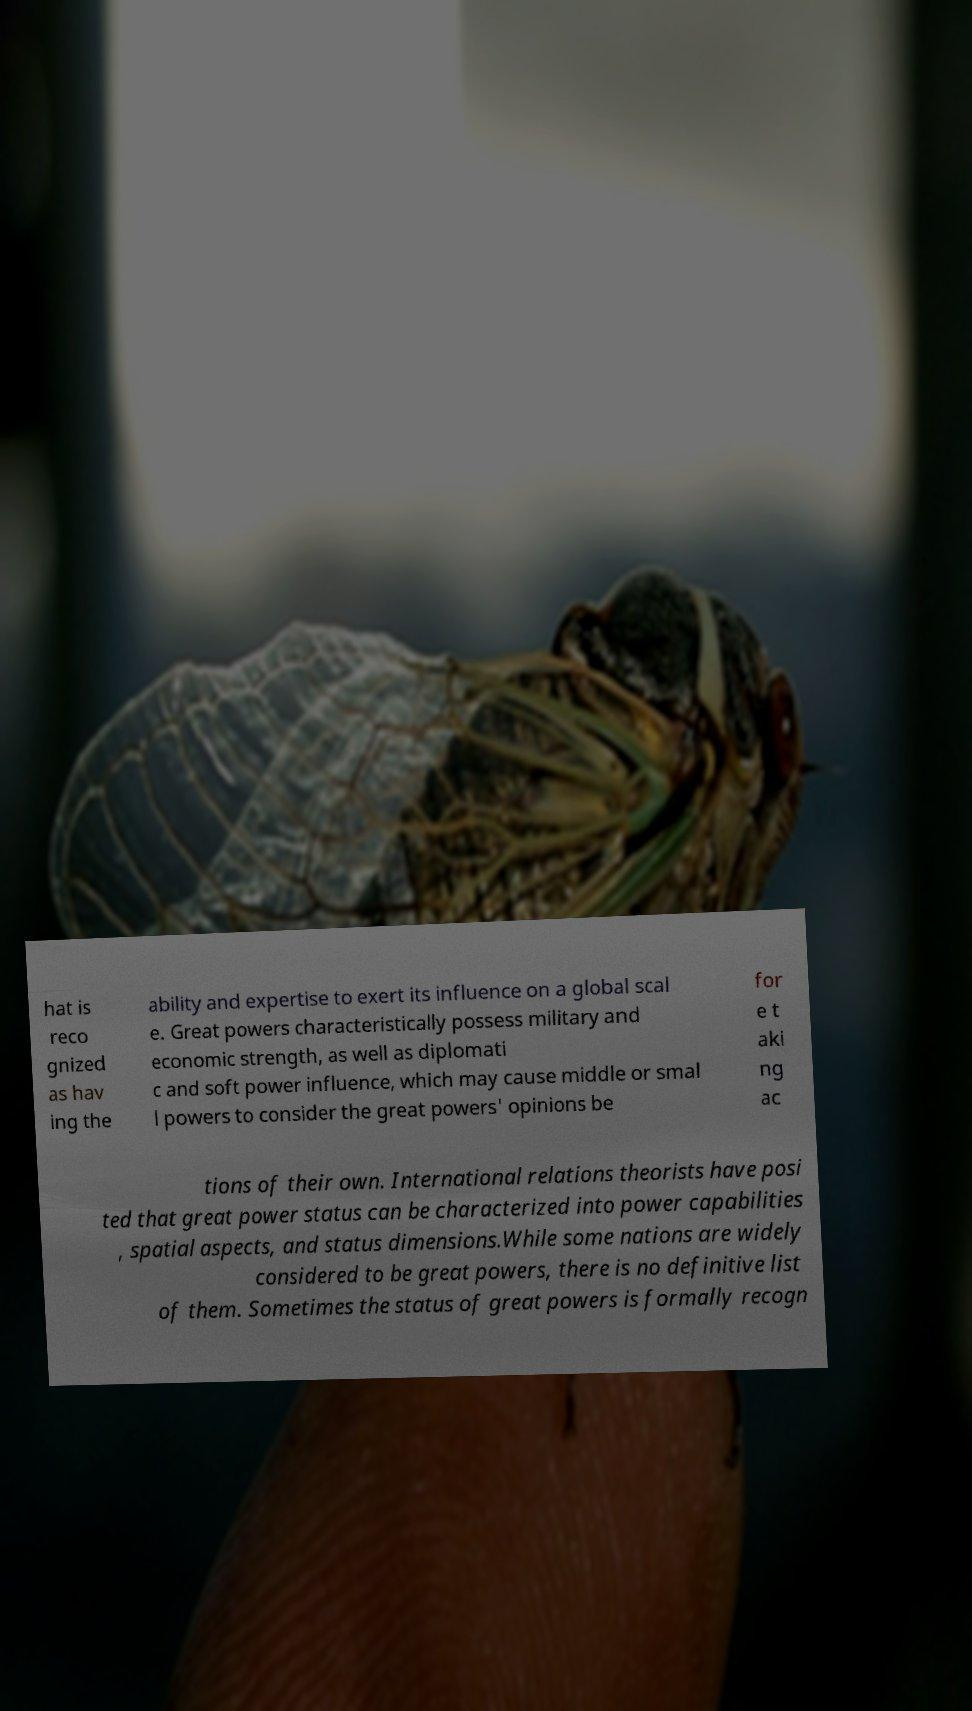For documentation purposes, I need the text within this image transcribed. Could you provide that? hat is reco gnized as hav ing the ability and expertise to exert its influence on a global scal e. Great powers characteristically possess military and economic strength, as well as diplomati c and soft power influence, which may cause middle or smal l powers to consider the great powers' opinions be for e t aki ng ac tions of their own. International relations theorists have posi ted that great power status can be characterized into power capabilities , spatial aspects, and status dimensions.While some nations are widely considered to be great powers, there is no definitive list of them. Sometimes the status of great powers is formally recogn 